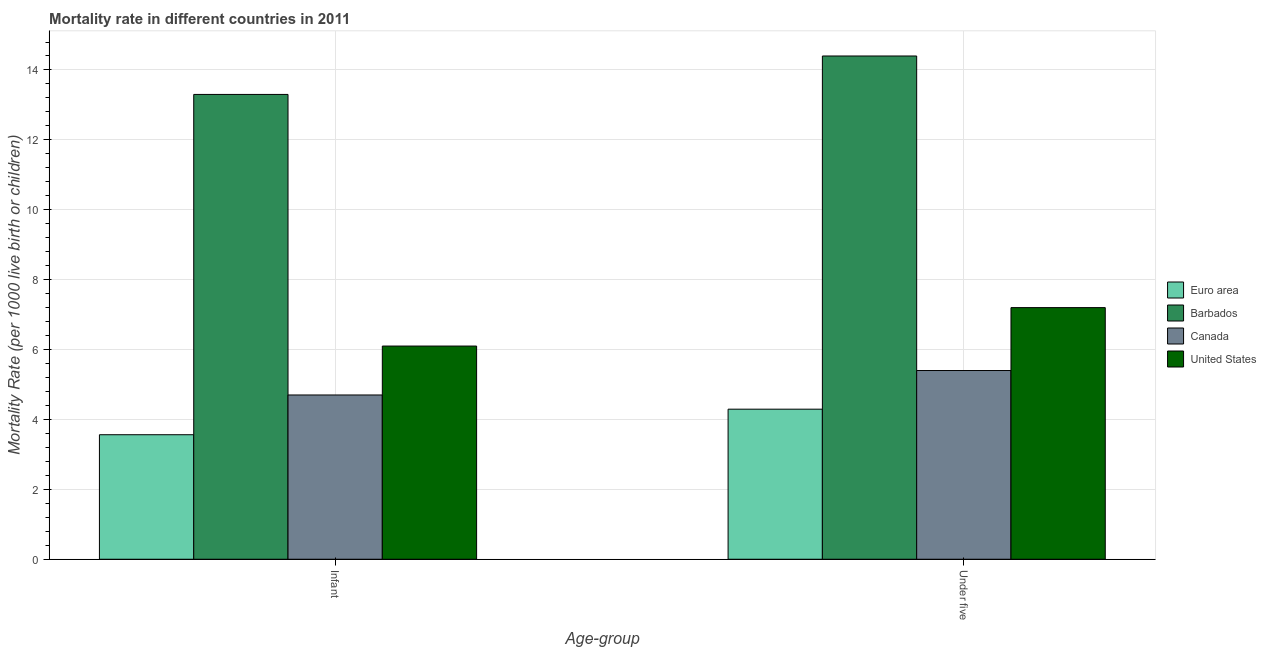Are the number of bars on each tick of the X-axis equal?
Make the answer very short. Yes. What is the label of the 1st group of bars from the left?
Your response must be concise. Infant. What is the under-5 mortality rate in United States?
Your answer should be compact. 7.2. Across all countries, what is the maximum under-5 mortality rate?
Provide a succinct answer. 14.4. Across all countries, what is the minimum infant mortality rate?
Give a very brief answer. 3.56. In which country was the under-5 mortality rate maximum?
Provide a succinct answer. Barbados. What is the total under-5 mortality rate in the graph?
Make the answer very short. 31.29. What is the difference between the under-5 mortality rate in Euro area and that in United States?
Give a very brief answer. -2.91. What is the average infant mortality rate per country?
Provide a short and direct response. 6.92. What is the difference between the infant mortality rate and under-5 mortality rate in Canada?
Your answer should be very brief. -0.7. In how many countries, is the under-5 mortality rate greater than 10.4 ?
Give a very brief answer. 1. What is the ratio of the infant mortality rate in Euro area to that in Barbados?
Provide a succinct answer. 0.27. Is the under-5 mortality rate in Euro area less than that in Barbados?
Provide a short and direct response. Yes. In how many countries, is the infant mortality rate greater than the average infant mortality rate taken over all countries?
Offer a very short reply. 1. What does the 3rd bar from the left in Infant represents?
Make the answer very short. Canada. What does the 3rd bar from the right in Under five represents?
Ensure brevity in your answer.  Barbados. Are all the bars in the graph horizontal?
Ensure brevity in your answer.  No. What is the difference between two consecutive major ticks on the Y-axis?
Keep it short and to the point. 2. Does the graph contain any zero values?
Provide a short and direct response. No. Does the graph contain grids?
Your answer should be very brief. Yes. Where does the legend appear in the graph?
Give a very brief answer. Center right. How are the legend labels stacked?
Offer a very short reply. Vertical. What is the title of the graph?
Your answer should be compact. Mortality rate in different countries in 2011. What is the label or title of the X-axis?
Offer a terse response. Age-group. What is the label or title of the Y-axis?
Your answer should be very brief. Mortality Rate (per 1000 live birth or children). What is the Mortality Rate (per 1000 live birth or children) in Euro area in Infant?
Your answer should be compact. 3.56. What is the Mortality Rate (per 1000 live birth or children) in Canada in Infant?
Your response must be concise. 4.7. What is the Mortality Rate (per 1000 live birth or children) in Euro area in Under five?
Make the answer very short. 4.29. What is the Mortality Rate (per 1000 live birth or children) in Canada in Under five?
Make the answer very short. 5.4. Across all Age-group, what is the maximum Mortality Rate (per 1000 live birth or children) of Euro area?
Offer a terse response. 4.29. Across all Age-group, what is the maximum Mortality Rate (per 1000 live birth or children) of Barbados?
Provide a succinct answer. 14.4. Across all Age-group, what is the minimum Mortality Rate (per 1000 live birth or children) of Euro area?
Make the answer very short. 3.56. Across all Age-group, what is the minimum Mortality Rate (per 1000 live birth or children) in Canada?
Ensure brevity in your answer.  4.7. What is the total Mortality Rate (per 1000 live birth or children) of Euro area in the graph?
Your answer should be compact. 7.86. What is the total Mortality Rate (per 1000 live birth or children) in Barbados in the graph?
Provide a short and direct response. 27.7. What is the total Mortality Rate (per 1000 live birth or children) in Canada in the graph?
Your response must be concise. 10.1. What is the total Mortality Rate (per 1000 live birth or children) in United States in the graph?
Offer a terse response. 13.3. What is the difference between the Mortality Rate (per 1000 live birth or children) in Euro area in Infant and that in Under five?
Provide a succinct answer. -0.73. What is the difference between the Mortality Rate (per 1000 live birth or children) in Barbados in Infant and that in Under five?
Give a very brief answer. -1.1. What is the difference between the Mortality Rate (per 1000 live birth or children) of United States in Infant and that in Under five?
Provide a short and direct response. -1.1. What is the difference between the Mortality Rate (per 1000 live birth or children) in Euro area in Infant and the Mortality Rate (per 1000 live birth or children) in Barbados in Under five?
Your answer should be very brief. -10.84. What is the difference between the Mortality Rate (per 1000 live birth or children) of Euro area in Infant and the Mortality Rate (per 1000 live birth or children) of Canada in Under five?
Provide a succinct answer. -1.84. What is the difference between the Mortality Rate (per 1000 live birth or children) of Euro area in Infant and the Mortality Rate (per 1000 live birth or children) of United States in Under five?
Provide a short and direct response. -3.64. What is the average Mortality Rate (per 1000 live birth or children) in Euro area per Age-group?
Offer a terse response. 3.93. What is the average Mortality Rate (per 1000 live birth or children) of Barbados per Age-group?
Provide a short and direct response. 13.85. What is the average Mortality Rate (per 1000 live birth or children) of Canada per Age-group?
Your answer should be very brief. 5.05. What is the average Mortality Rate (per 1000 live birth or children) of United States per Age-group?
Provide a short and direct response. 6.65. What is the difference between the Mortality Rate (per 1000 live birth or children) in Euro area and Mortality Rate (per 1000 live birth or children) in Barbados in Infant?
Offer a very short reply. -9.74. What is the difference between the Mortality Rate (per 1000 live birth or children) of Euro area and Mortality Rate (per 1000 live birth or children) of Canada in Infant?
Offer a very short reply. -1.14. What is the difference between the Mortality Rate (per 1000 live birth or children) of Euro area and Mortality Rate (per 1000 live birth or children) of United States in Infant?
Your answer should be very brief. -2.54. What is the difference between the Mortality Rate (per 1000 live birth or children) in Canada and Mortality Rate (per 1000 live birth or children) in United States in Infant?
Make the answer very short. -1.4. What is the difference between the Mortality Rate (per 1000 live birth or children) of Euro area and Mortality Rate (per 1000 live birth or children) of Barbados in Under five?
Offer a terse response. -10.11. What is the difference between the Mortality Rate (per 1000 live birth or children) of Euro area and Mortality Rate (per 1000 live birth or children) of Canada in Under five?
Offer a very short reply. -1.11. What is the difference between the Mortality Rate (per 1000 live birth or children) in Euro area and Mortality Rate (per 1000 live birth or children) in United States in Under five?
Offer a very short reply. -2.91. What is the difference between the Mortality Rate (per 1000 live birth or children) of Barbados and Mortality Rate (per 1000 live birth or children) of Canada in Under five?
Keep it short and to the point. 9. What is the ratio of the Mortality Rate (per 1000 live birth or children) in Euro area in Infant to that in Under five?
Your response must be concise. 0.83. What is the ratio of the Mortality Rate (per 1000 live birth or children) of Barbados in Infant to that in Under five?
Keep it short and to the point. 0.92. What is the ratio of the Mortality Rate (per 1000 live birth or children) in Canada in Infant to that in Under five?
Your answer should be compact. 0.87. What is the ratio of the Mortality Rate (per 1000 live birth or children) of United States in Infant to that in Under five?
Make the answer very short. 0.85. What is the difference between the highest and the second highest Mortality Rate (per 1000 live birth or children) of Euro area?
Make the answer very short. 0.73. What is the difference between the highest and the lowest Mortality Rate (per 1000 live birth or children) in Euro area?
Offer a terse response. 0.73. What is the difference between the highest and the lowest Mortality Rate (per 1000 live birth or children) of Barbados?
Your answer should be compact. 1.1. 